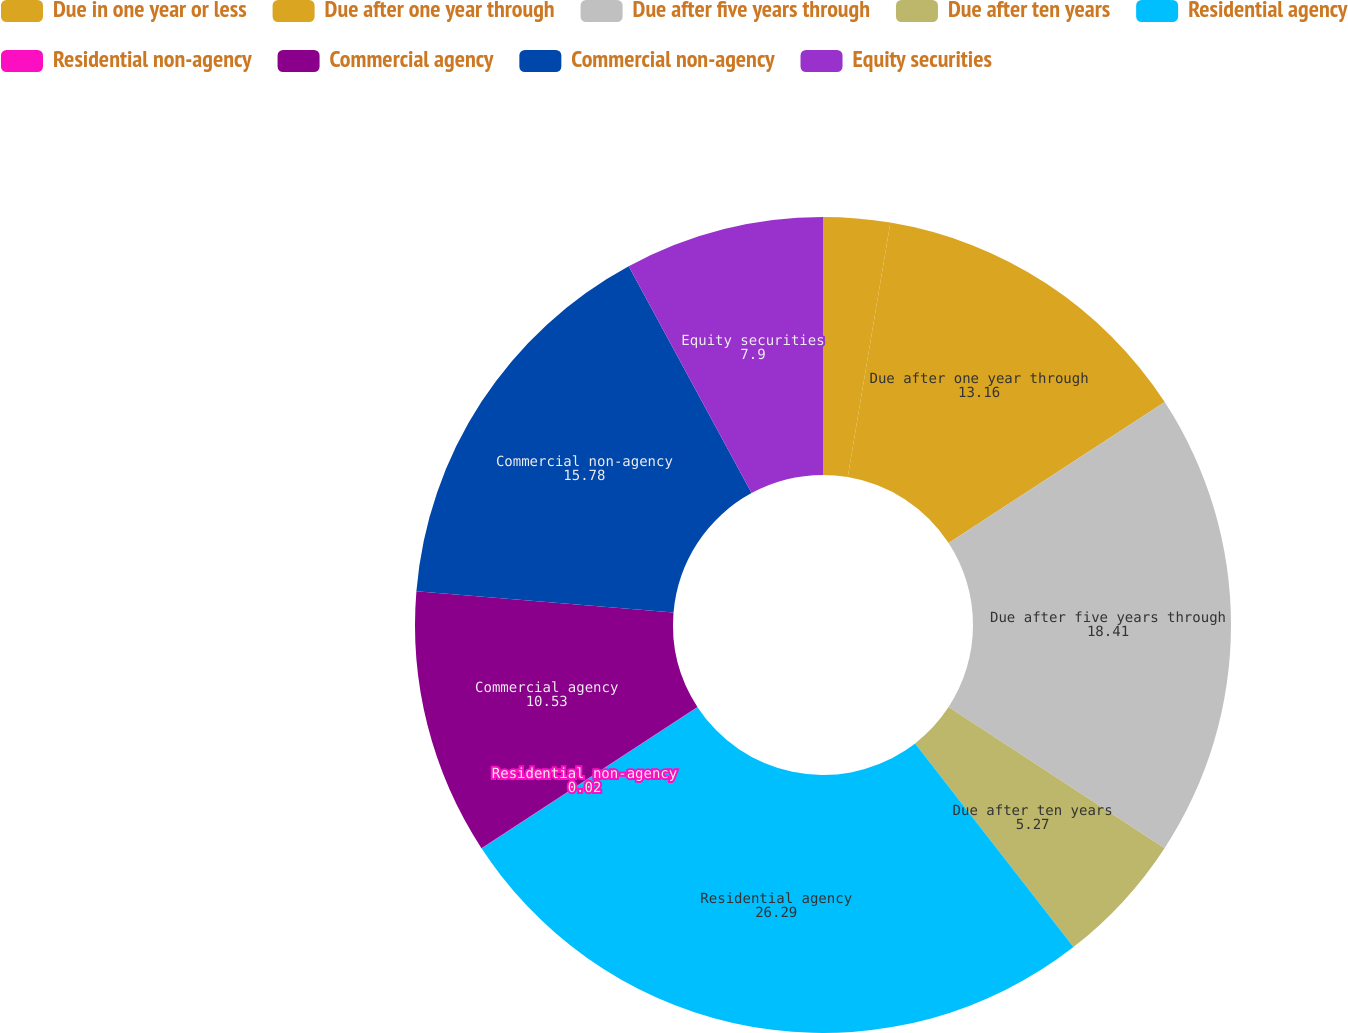Convert chart to OTSL. <chart><loc_0><loc_0><loc_500><loc_500><pie_chart><fcel>Due in one year or less<fcel>Due after one year through<fcel>Due after five years through<fcel>Due after ten years<fcel>Residential agency<fcel>Residential non-agency<fcel>Commercial agency<fcel>Commercial non-agency<fcel>Equity securities<nl><fcel>2.64%<fcel>13.16%<fcel>18.41%<fcel>5.27%<fcel>26.29%<fcel>0.02%<fcel>10.53%<fcel>15.78%<fcel>7.9%<nl></chart> 